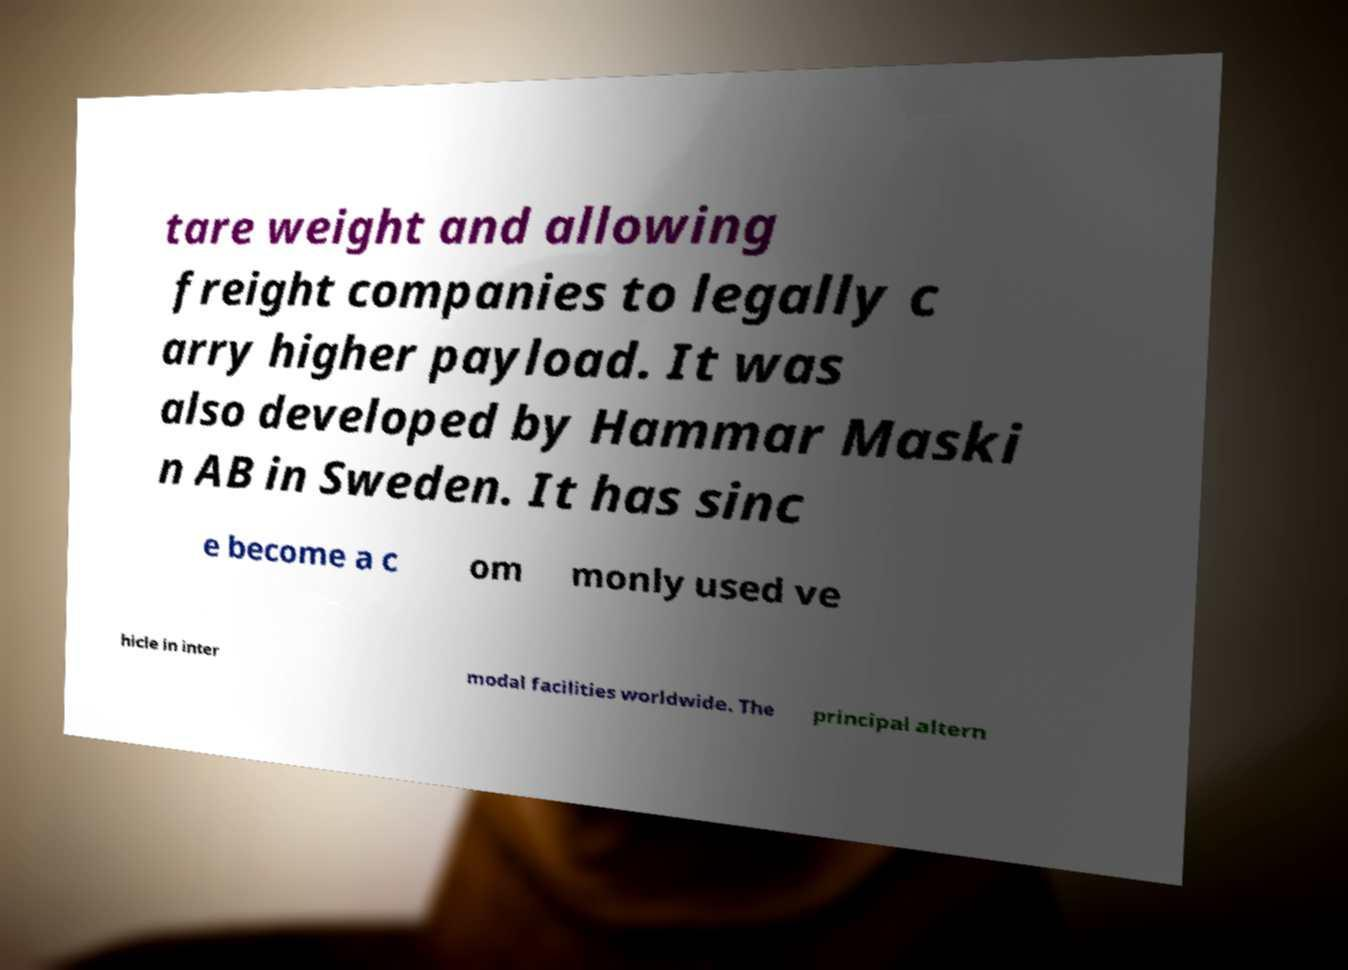What messages or text are displayed in this image? I need them in a readable, typed format. tare weight and allowing freight companies to legally c arry higher payload. It was also developed by Hammar Maski n AB in Sweden. It has sinc e become a c om monly used ve hicle in inter modal facilities worldwide. The principal altern 